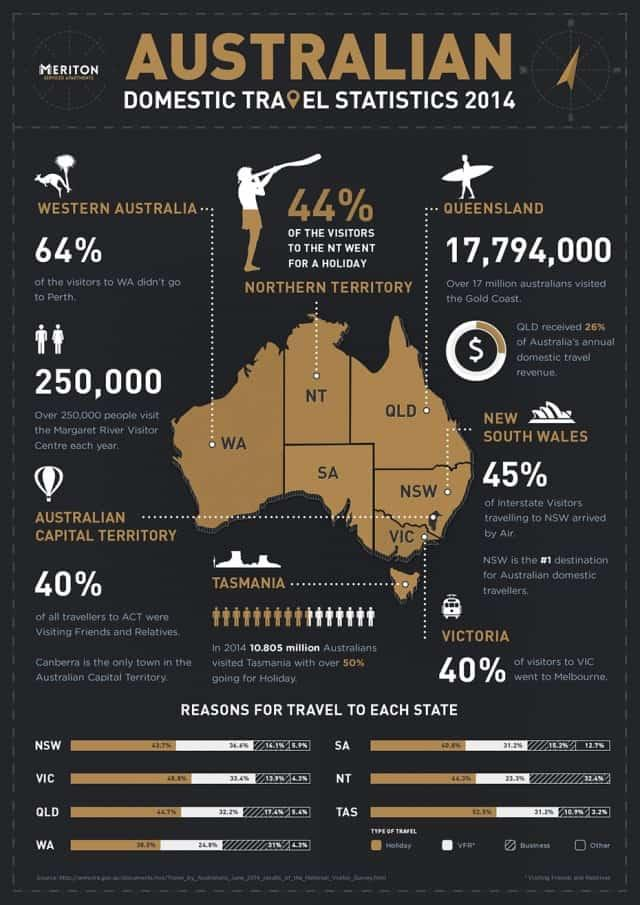Give some essential details in this illustration. I counted 7 states mentioned in Australia. Canberra is the only town located in the Australian Capital Territory. In the year 2014, the least visited domestic destination in Western Australia was Perth. According to data collected in 2014, the most popular mode of transport for travellers visiting New South Wales was air travel. Six in ten visitors to Victoria did not go to Melbourne. 